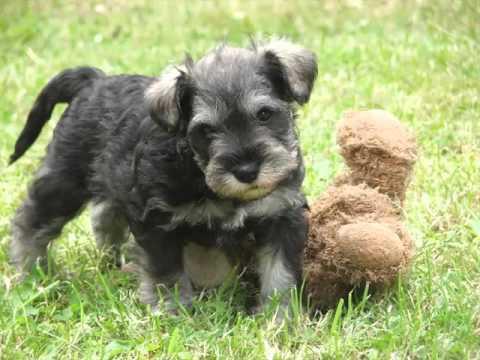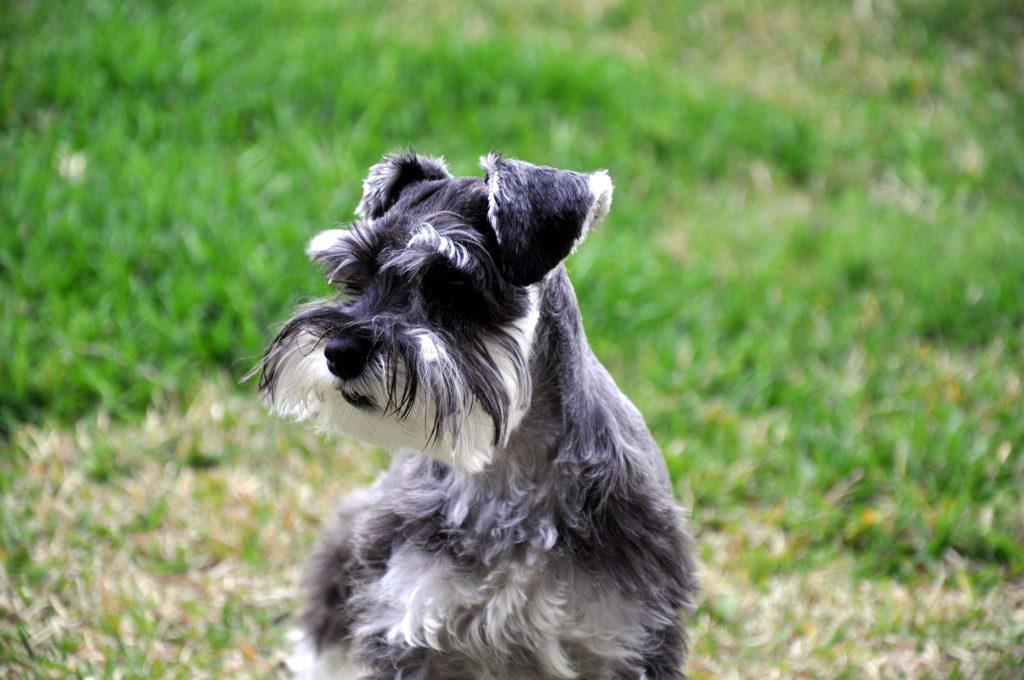The first image is the image on the left, the second image is the image on the right. For the images displayed, is the sentence "The dogs in both images are looking forward." factually correct? Answer yes or no. No. 